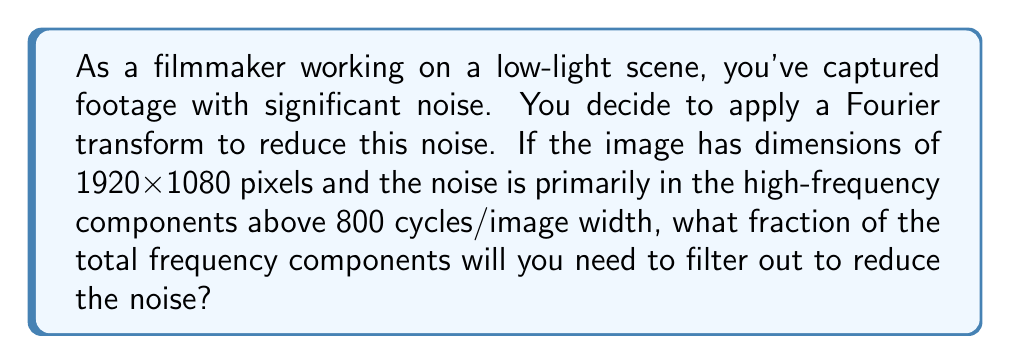Solve this math problem. To solve this problem, we need to follow these steps:

1) First, let's understand what the Fourier transform does to an image. It converts the image from the spatial domain to the frequency domain, representing it as a sum of sinusoidal components.

2) For a 2D image, the Fourier transform produces a 2D frequency spectrum. The dimensions of this spectrum match the dimensions of the original image.

3) In this case, our image is 1920x1080 pixels. The Fourier transform will produce a frequency spectrum of the same size.

4) The total number of frequency components is thus:

   $$N_{total} = 1920 \times 1080 = 2,073,600$$

5) The question states that noise is primarily in high-frequency components above 800 cycles/image width. This means we need to filter out frequencies higher than 800 cycles in both dimensions.

6) In the frequency domain, the components we want to keep are in a 1600x900 rectangle at the center of the spectrum (800 cycles in each direction from the center).

7) The number of components we're keeping is:

   $$N_{keep} = 1600 \times 900 = 1,440,000$$

8) Therefore, the number of components we're filtering out is:

   $$N_{filter} = N_{total} - N_{keep} = 2,073,600 - 1,440,000 = 633,600$$

9) The fraction of components we're filtering out is:

   $$\frac{N_{filter}}{N_{total}} = \frac{633,600}{2,073,600} = \frac{30.5556}{100} \approx 0.3056$$
Answer: Approximately 0.3056 or 30.56% of the total frequency components need to be filtered out. 